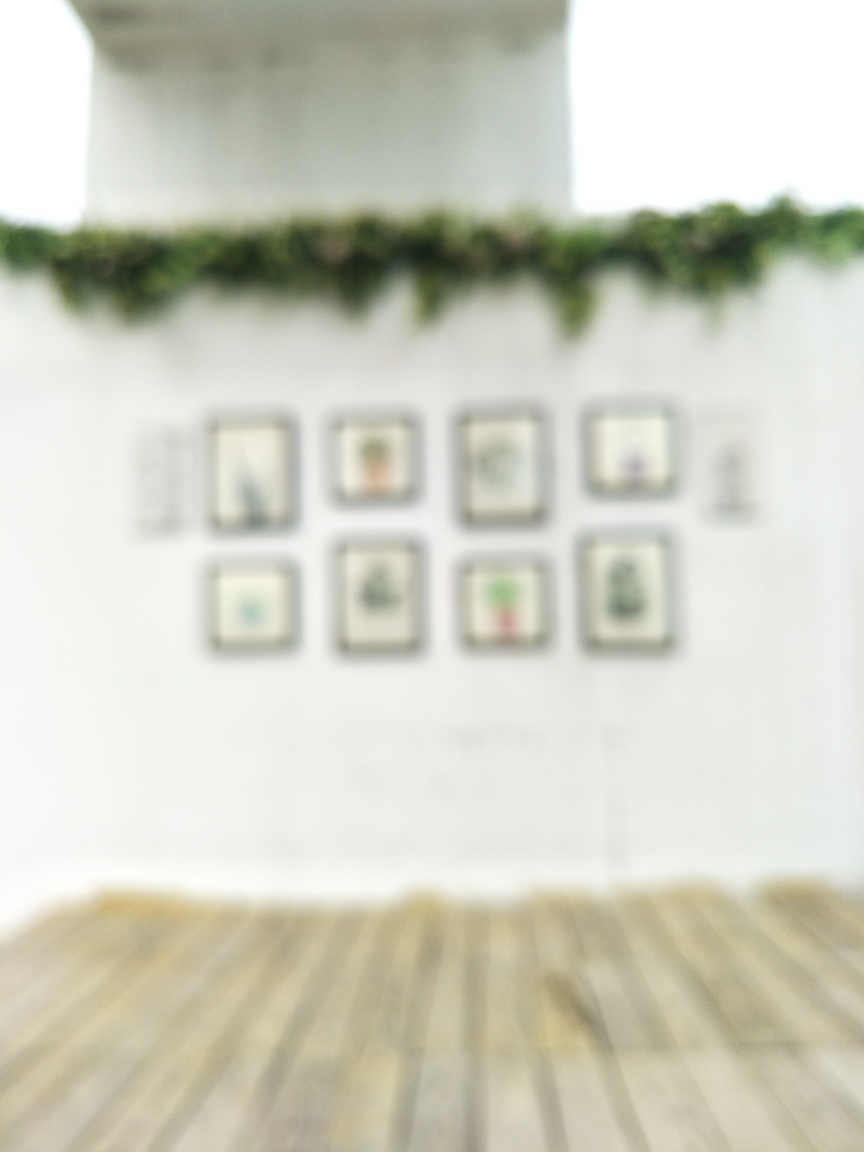Can you suggest how the image might be enhanced to improve its clarity? To enhance the clarity of the image, one could use photo editing software to apply sharpening filters, adjust the contrast and brightness levels, or potentially use AI algorithms designed to deblur images and improve their resolution. 